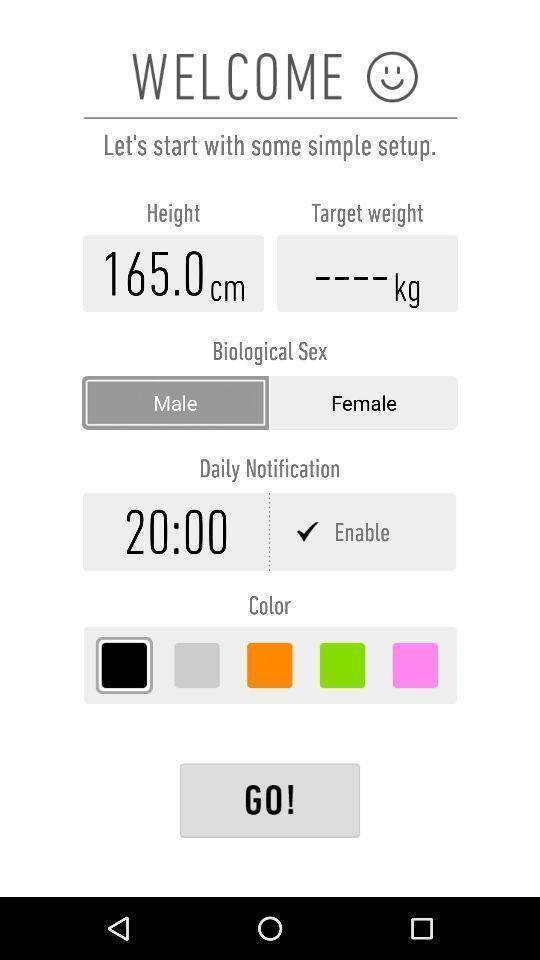Describe the visual elements of this screenshot. Welcome page. 